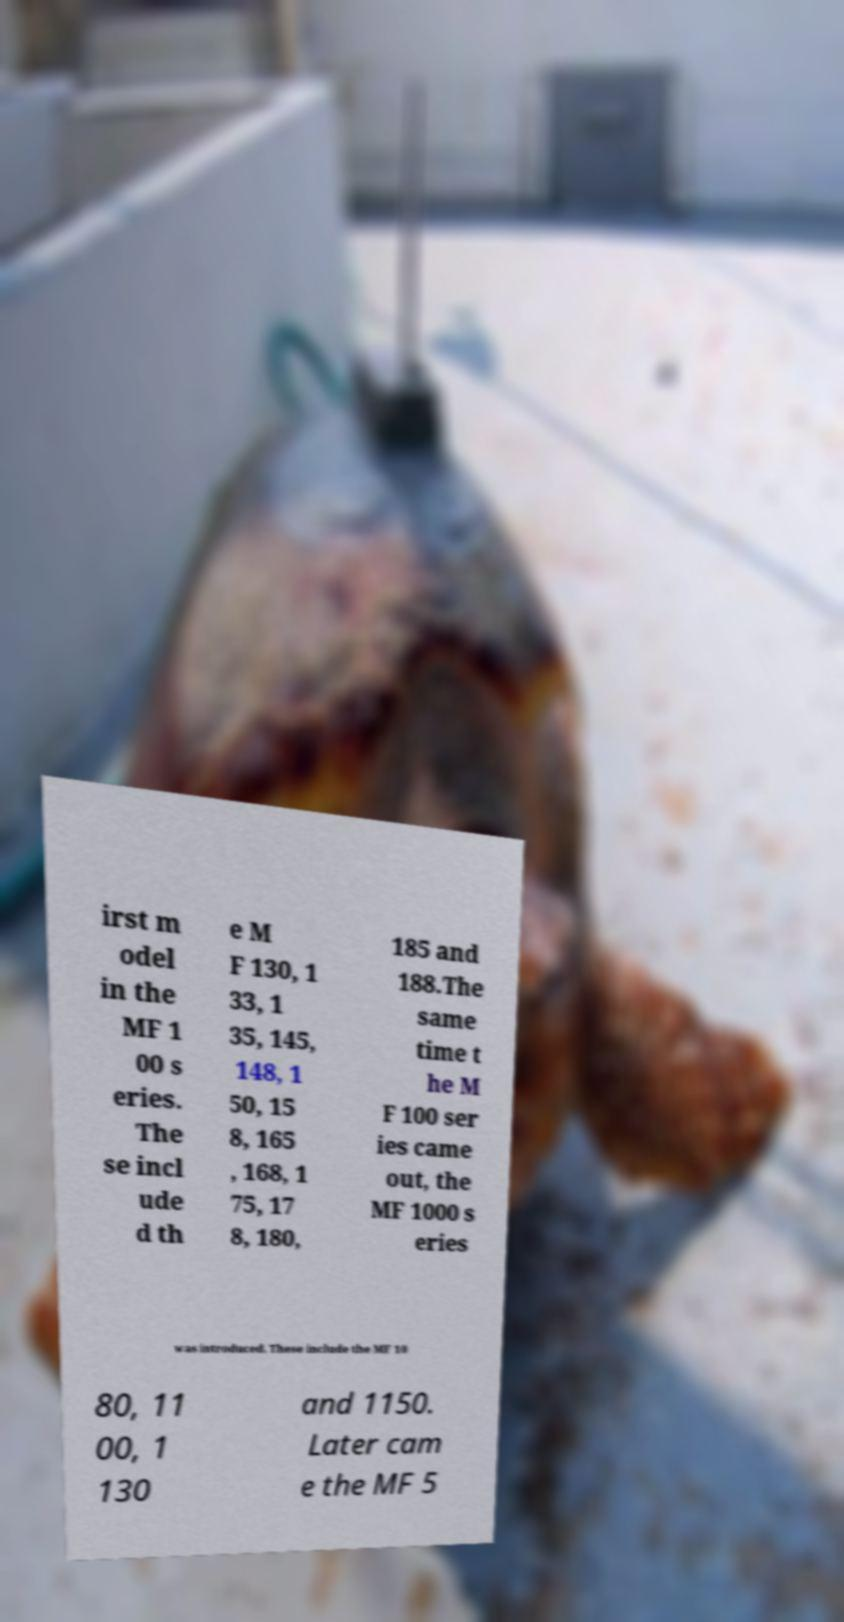Can you accurately transcribe the text from the provided image for me? irst m odel in the MF 1 00 s eries. The se incl ude d th e M F 130, 1 33, 1 35, 145, 148, 1 50, 15 8, 165 , 168, 1 75, 17 8, 180, 185 and 188.The same time t he M F 100 ser ies came out, the MF 1000 s eries was introduced. These include the MF 10 80, 11 00, 1 130 and 1150. Later cam e the MF 5 